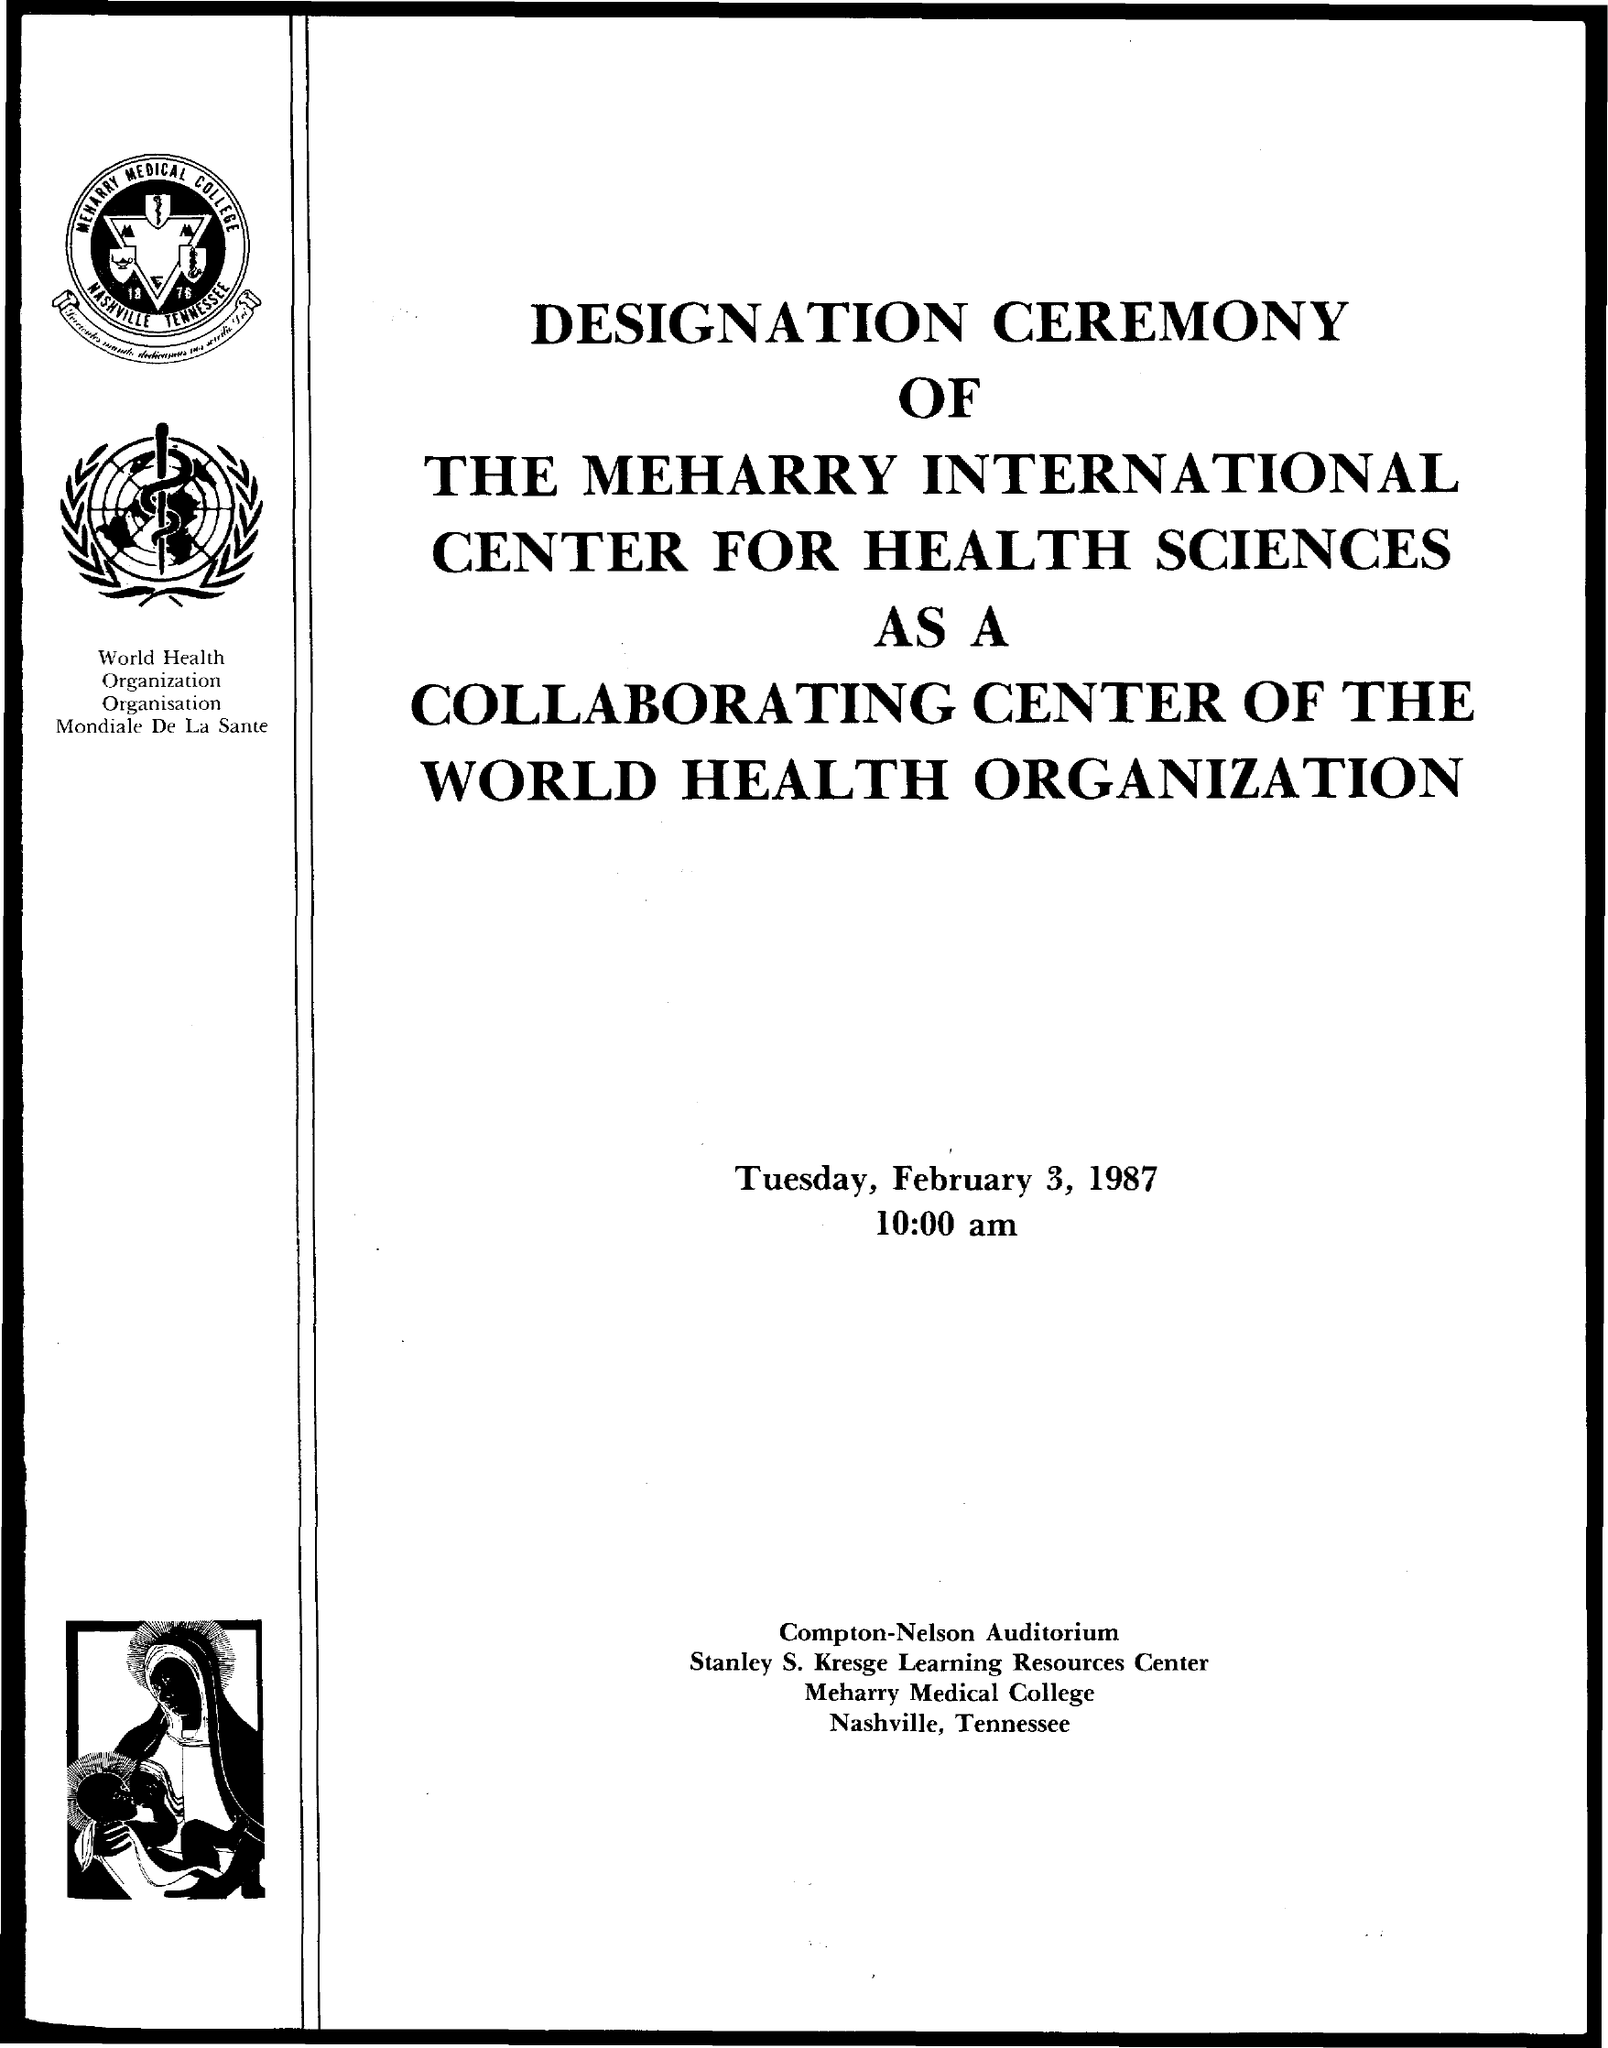What is the date mentioned in the given page ?
Offer a very short reply. February 3, 1987. What is the time mentioned ?
Your answer should be very brief. 10:00 am. What is the name of the college mentioned ?
Your answer should be very brief. MEHARRY MEDICAL COLLEGE. 